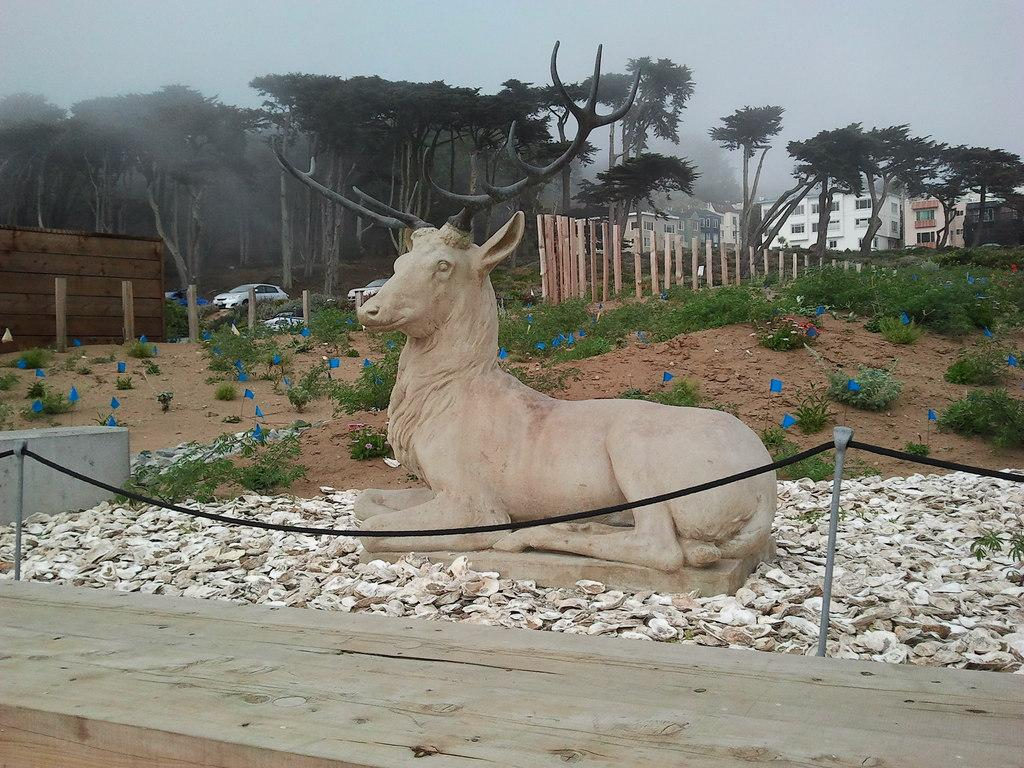What is the main subject in the center of the image? There is a sculpture in the center of the image. What can be seen at the bottom of the image? There is a walkway and rocks present at the bottom of the image. What is visible in the background of the image? In the background of the image, there are trees, a fence, buildings, and the sky. Can you describe the setting of the image? The image appears to be set in an outdoor area with a sculpture, walkway, rocks, and various background elements. How many lizards are sitting on the twig in the image? There are no lizards or twigs present in the image. What type of club is visible in the background of the image? There is no club visible in the background of the image. 